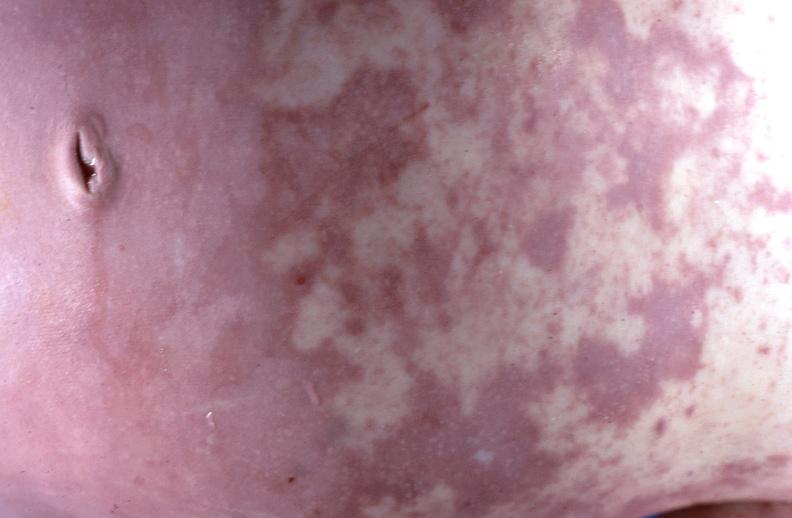what does this image show?
Answer the question using a single word or phrase. Gram negative septicemia due to scalp electrode in a neonate 